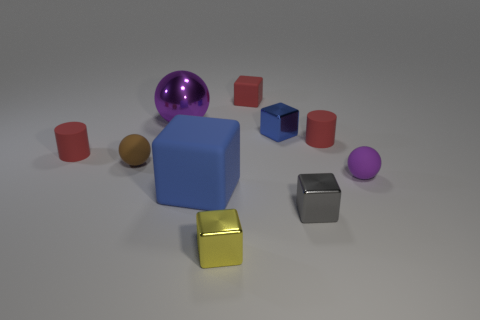Subtract all small matte balls. How many balls are left? 1 Subtract all purple balls. How many balls are left? 1 Subtract 4 blocks. How many blocks are left? 1 Subtract all cylinders. How many objects are left? 8 Subtract all gray balls. How many gray blocks are left? 1 Subtract 0 blue cylinders. How many objects are left? 10 Subtract all purple cylinders. Subtract all red blocks. How many cylinders are left? 2 Subtract all small blue metal things. Subtract all big yellow metal spheres. How many objects are left? 9 Add 3 large rubber cubes. How many large rubber cubes are left? 4 Add 6 large purple balls. How many large purple balls exist? 7 